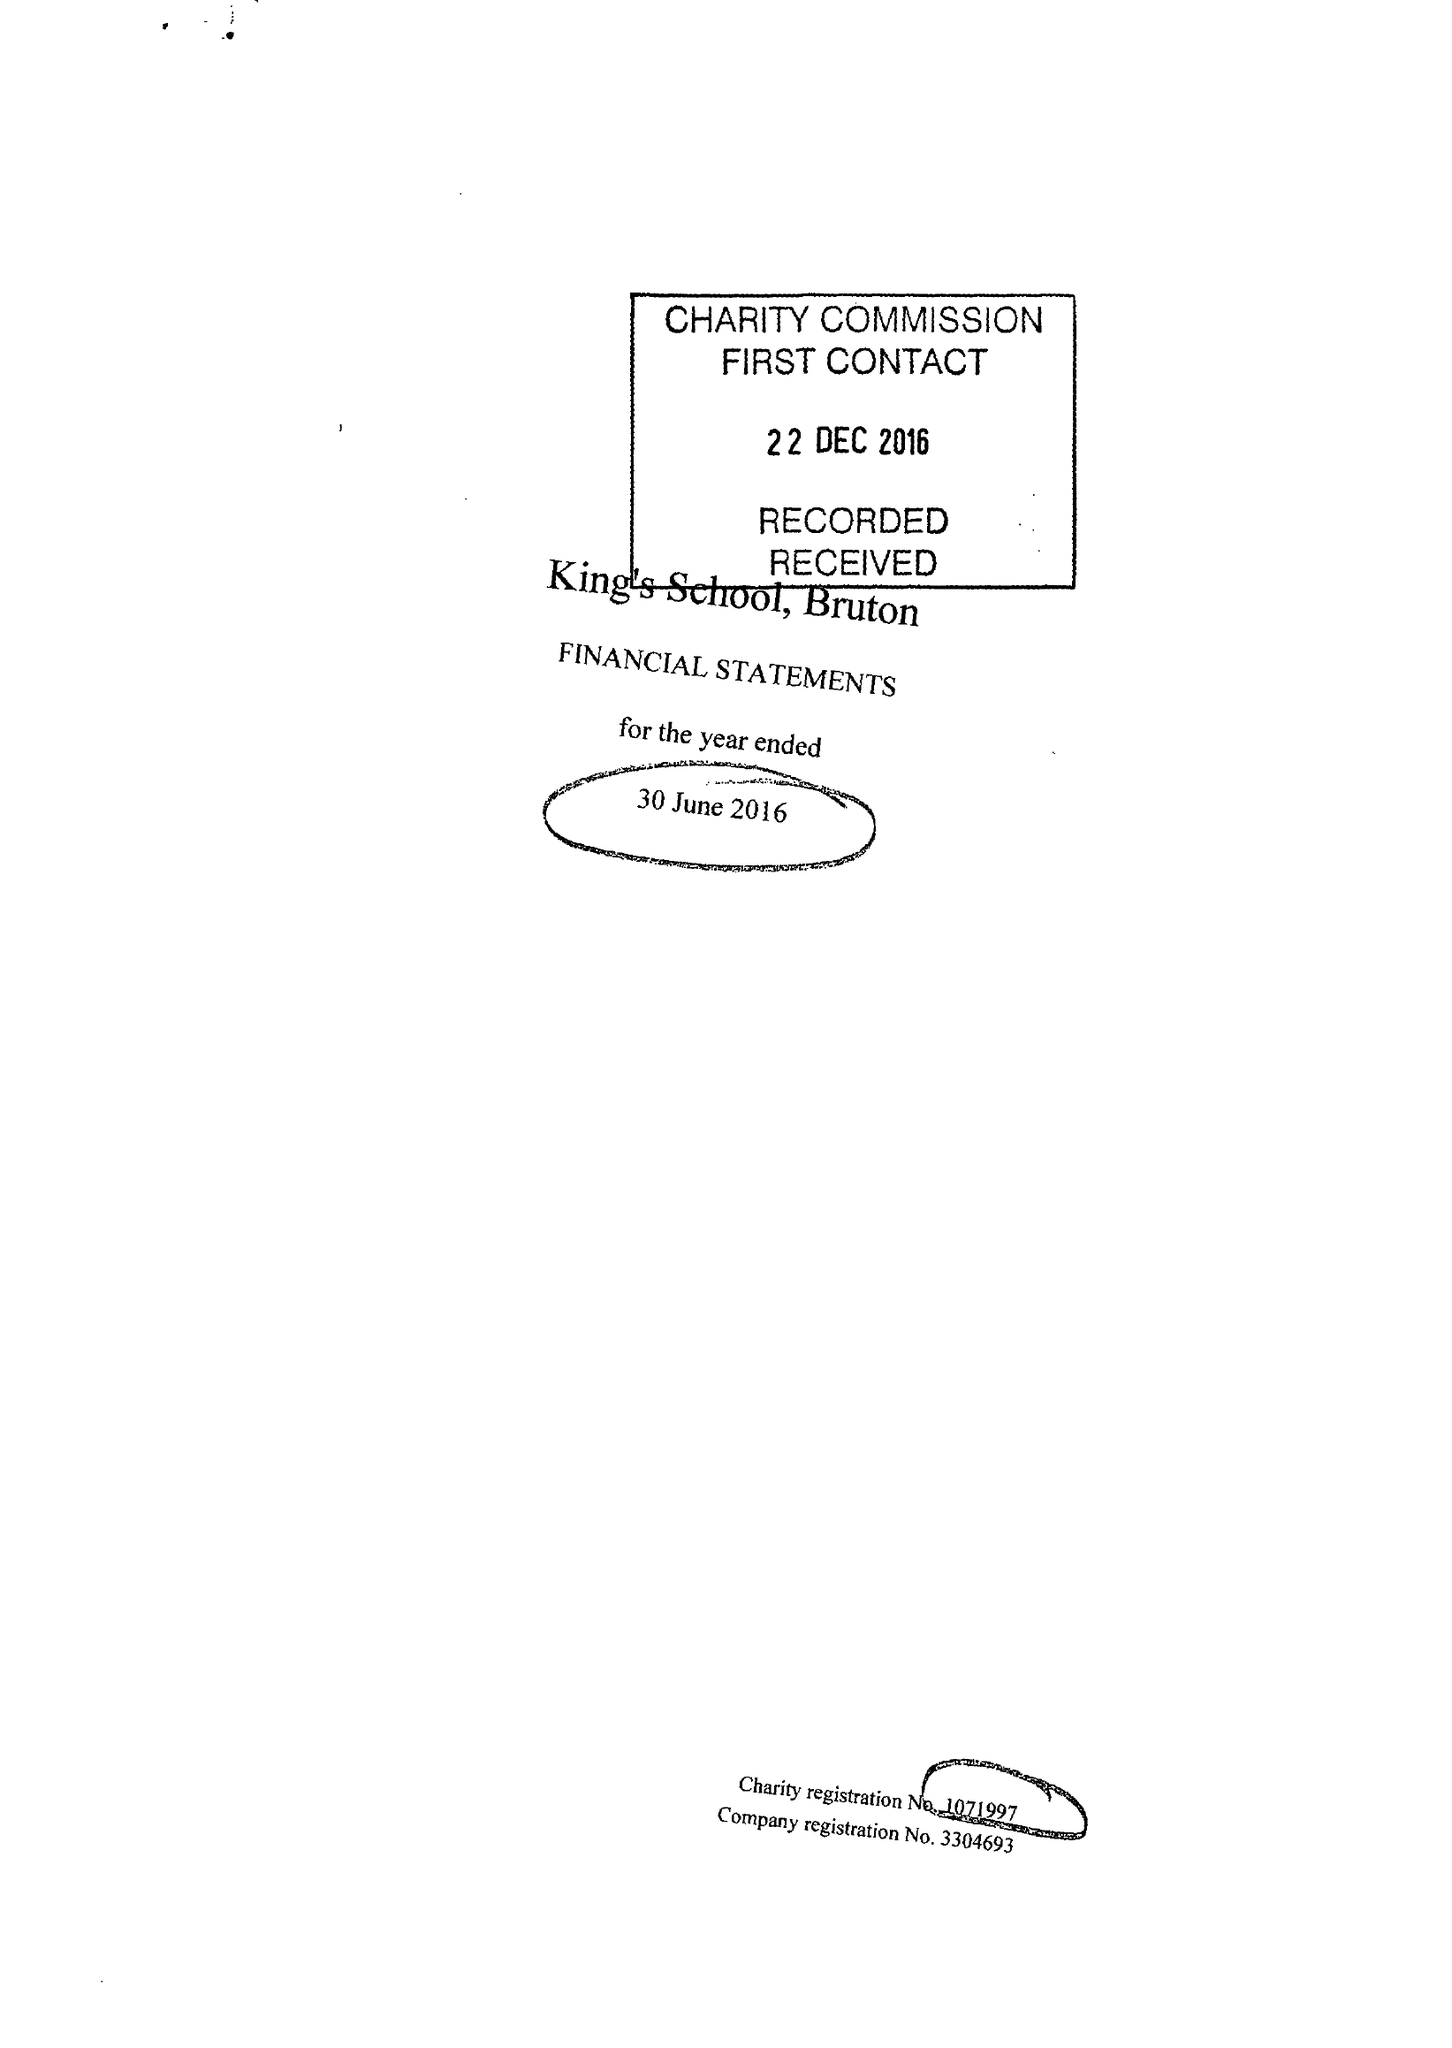What is the value for the address__postcode?
Answer the question using a single word or phrase. BA10 0ED 